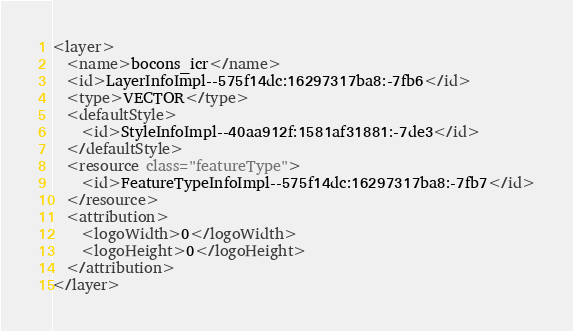Convert code to text. <code><loc_0><loc_0><loc_500><loc_500><_XML_><layer>
  <name>bocons_icr</name>
  <id>LayerInfoImpl--575f14dc:16297317ba8:-7fb6</id>
  <type>VECTOR</type>
  <defaultStyle>
    <id>StyleInfoImpl--40aa912f:1581af31881:-7de3</id>
  </defaultStyle>
  <resource class="featureType">
    <id>FeatureTypeInfoImpl--575f14dc:16297317ba8:-7fb7</id>
  </resource>
  <attribution>
    <logoWidth>0</logoWidth>
    <logoHeight>0</logoHeight>
  </attribution>
</layer></code> 